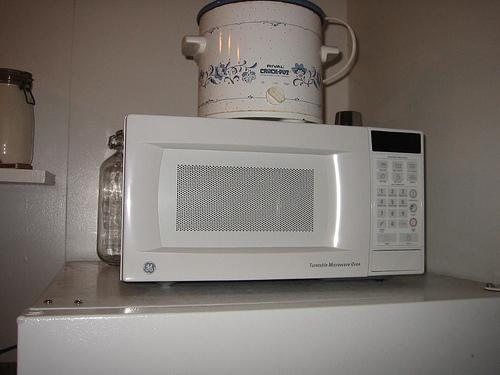Which object has a door that opens? microwave 